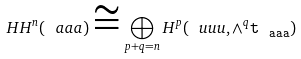<formula> <loc_0><loc_0><loc_500><loc_500>H H ^ { n } ( \ a a a ) \cong \bigoplus _ { p + q = n } H ^ { p } ( \ u u u , \wedge ^ { q } \tt t _ { \ a a a } )</formula> 